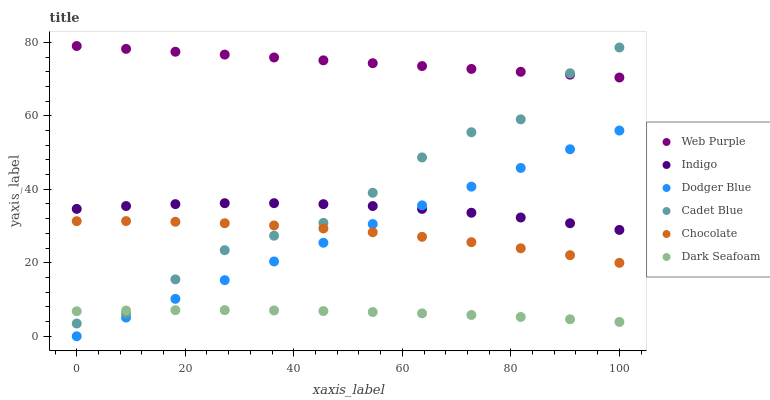Does Dark Seafoam have the minimum area under the curve?
Answer yes or no. Yes. Does Web Purple have the maximum area under the curve?
Answer yes or no. Yes. Does Indigo have the minimum area under the curve?
Answer yes or no. No. Does Indigo have the maximum area under the curve?
Answer yes or no. No. Is Dodger Blue the smoothest?
Answer yes or no. Yes. Is Cadet Blue the roughest?
Answer yes or no. Yes. Is Indigo the smoothest?
Answer yes or no. No. Is Indigo the roughest?
Answer yes or no. No. Does Dodger Blue have the lowest value?
Answer yes or no. Yes. Does Indigo have the lowest value?
Answer yes or no. No. Does Web Purple have the highest value?
Answer yes or no. Yes. Does Indigo have the highest value?
Answer yes or no. No. Is Dodger Blue less than Web Purple?
Answer yes or no. Yes. Is Chocolate greater than Dark Seafoam?
Answer yes or no. Yes. Does Dodger Blue intersect Indigo?
Answer yes or no. Yes. Is Dodger Blue less than Indigo?
Answer yes or no. No. Is Dodger Blue greater than Indigo?
Answer yes or no. No. Does Dodger Blue intersect Web Purple?
Answer yes or no. No. 